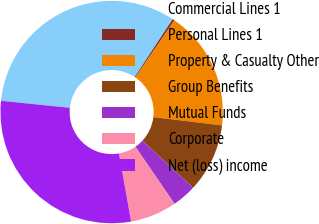Convert chart to OTSL. <chart><loc_0><loc_0><loc_500><loc_500><pie_chart><fcel>Commercial Lines 1<fcel>Personal Lines 1<fcel>Property & Casualty Other<fcel>Group Benefits<fcel>Mutual Funds<fcel>Corporate<fcel>Net (loss) income<nl><fcel>32.64%<fcel>0.3%<fcel>17.36%<fcel>10.0%<fcel>3.53%<fcel>6.76%<fcel>29.41%<nl></chart> 